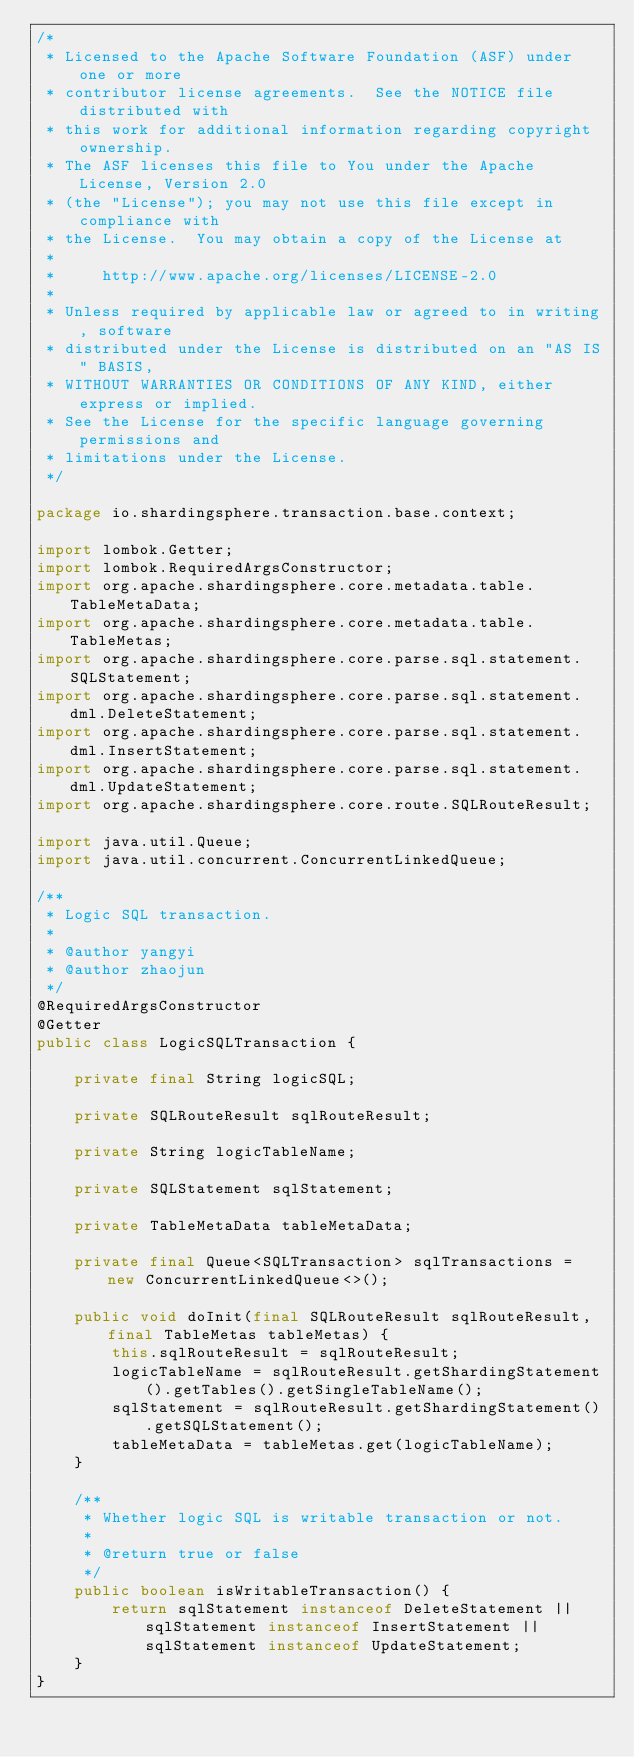<code> <loc_0><loc_0><loc_500><loc_500><_Java_>/*
 * Licensed to the Apache Software Foundation (ASF) under one or more
 * contributor license agreements.  See the NOTICE file distributed with
 * this work for additional information regarding copyright ownership.
 * The ASF licenses this file to You under the Apache License, Version 2.0
 * (the "License"); you may not use this file except in compliance with
 * the License.  You may obtain a copy of the License at
 *
 *     http://www.apache.org/licenses/LICENSE-2.0
 *
 * Unless required by applicable law or agreed to in writing, software
 * distributed under the License is distributed on an "AS IS" BASIS,
 * WITHOUT WARRANTIES OR CONDITIONS OF ANY KIND, either express or implied.
 * See the License for the specific language governing permissions and
 * limitations under the License.
 */

package io.shardingsphere.transaction.base.context;

import lombok.Getter;
import lombok.RequiredArgsConstructor;
import org.apache.shardingsphere.core.metadata.table.TableMetaData;
import org.apache.shardingsphere.core.metadata.table.TableMetas;
import org.apache.shardingsphere.core.parse.sql.statement.SQLStatement;
import org.apache.shardingsphere.core.parse.sql.statement.dml.DeleteStatement;
import org.apache.shardingsphere.core.parse.sql.statement.dml.InsertStatement;
import org.apache.shardingsphere.core.parse.sql.statement.dml.UpdateStatement;
import org.apache.shardingsphere.core.route.SQLRouteResult;

import java.util.Queue;
import java.util.concurrent.ConcurrentLinkedQueue;

/**
 * Logic SQL transaction.
 *
 * @author yangyi
 * @author zhaojun
 */
@RequiredArgsConstructor
@Getter
public class LogicSQLTransaction {
    
    private final String logicSQL;
    
    private SQLRouteResult sqlRouteResult;
    
    private String logicTableName;
    
    private SQLStatement sqlStatement;
    
    private TableMetaData tableMetaData;
    
    private final Queue<SQLTransaction> sqlTransactions = new ConcurrentLinkedQueue<>();
    
    public void doInit(final SQLRouteResult sqlRouteResult, final TableMetas tableMetas) {
        this.sqlRouteResult = sqlRouteResult;
        logicTableName = sqlRouteResult.getShardingStatement().getTables().getSingleTableName();
        sqlStatement = sqlRouteResult.getShardingStatement().getSQLStatement();
        tableMetaData = tableMetas.get(logicTableName);
    }
    
    /**
     * Whether logic SQL is writable transaction or not.
     *
     * @return true or false
     */
    public boolean isWritableTransaction() {
        return sqlStatement instanceof DeleteStatement || sqlStatement instanceof InsertStatement || sqlStatement instanceof UpdateStatement;
    }
}
</code> 